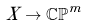<formula> <loc_0><loc_0><loc_500><loc_500>X \to \mathbb { C P } ^ { m }</formula> 